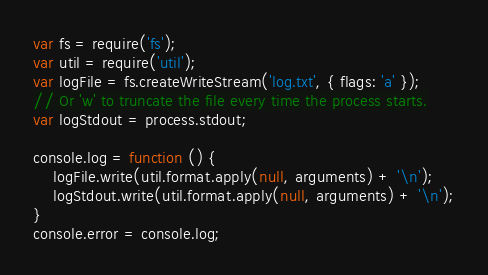Convert code to text. <code><loc_0><loc_0><loc_500><loc_500><_JavaScript_>var fs = require('fs');
var util = require('util');
var logFile = fs.createWriteStream('log.txt', { flags: 'a' });
// Or 'w' to truncate the file every time the process starts.
var logStdout = process.stdout;

console.log = function () {
    logFile.write(util.format.apply(null, arguments) + '\n');
    logStdout.write(util.format.apply(null, arguments) + '\n');
}
console.error = console.log;</code> 